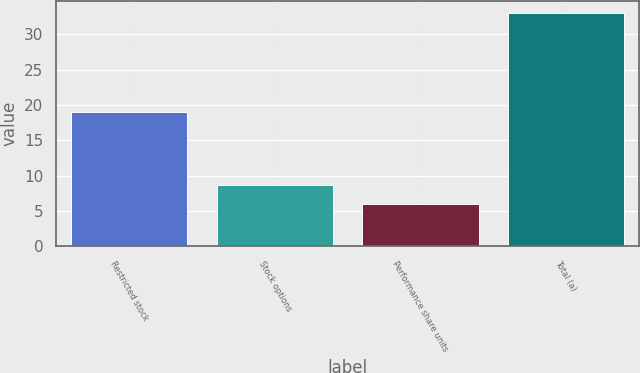Convert chart. <chart><loc_0><loc_0><loc_500><loc_500><bar_chart><fcel>Restricted stock<fcel>Stock options<fcel>Performance share units<fcel>Total (a)<nl><fcel>19<fcel>8.7<fcel>6<fcel>33<nl></chart> 